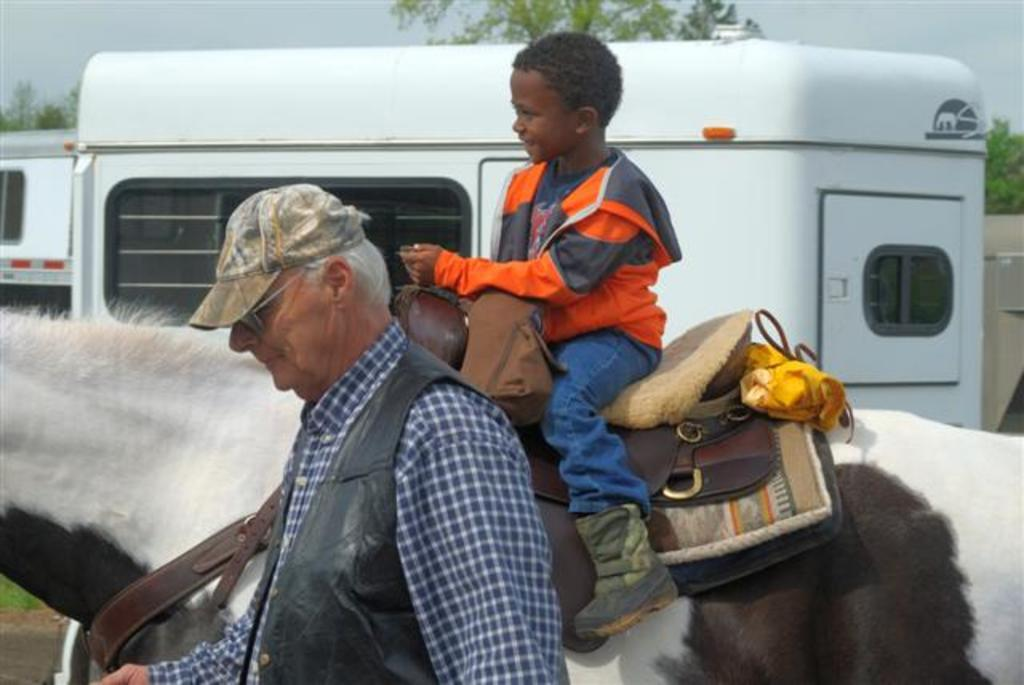What is the boy doing in the image? The boy is sitting on a horse in the image. Who is beside the horse in the image? There is a man beside the horse in the image. What can be seen in the background of the image? There are trucks and trees in the background of the image. What type of leg is the pig using to walk in the image? There is no pig present in the image, so it is not possible to answer that question. 